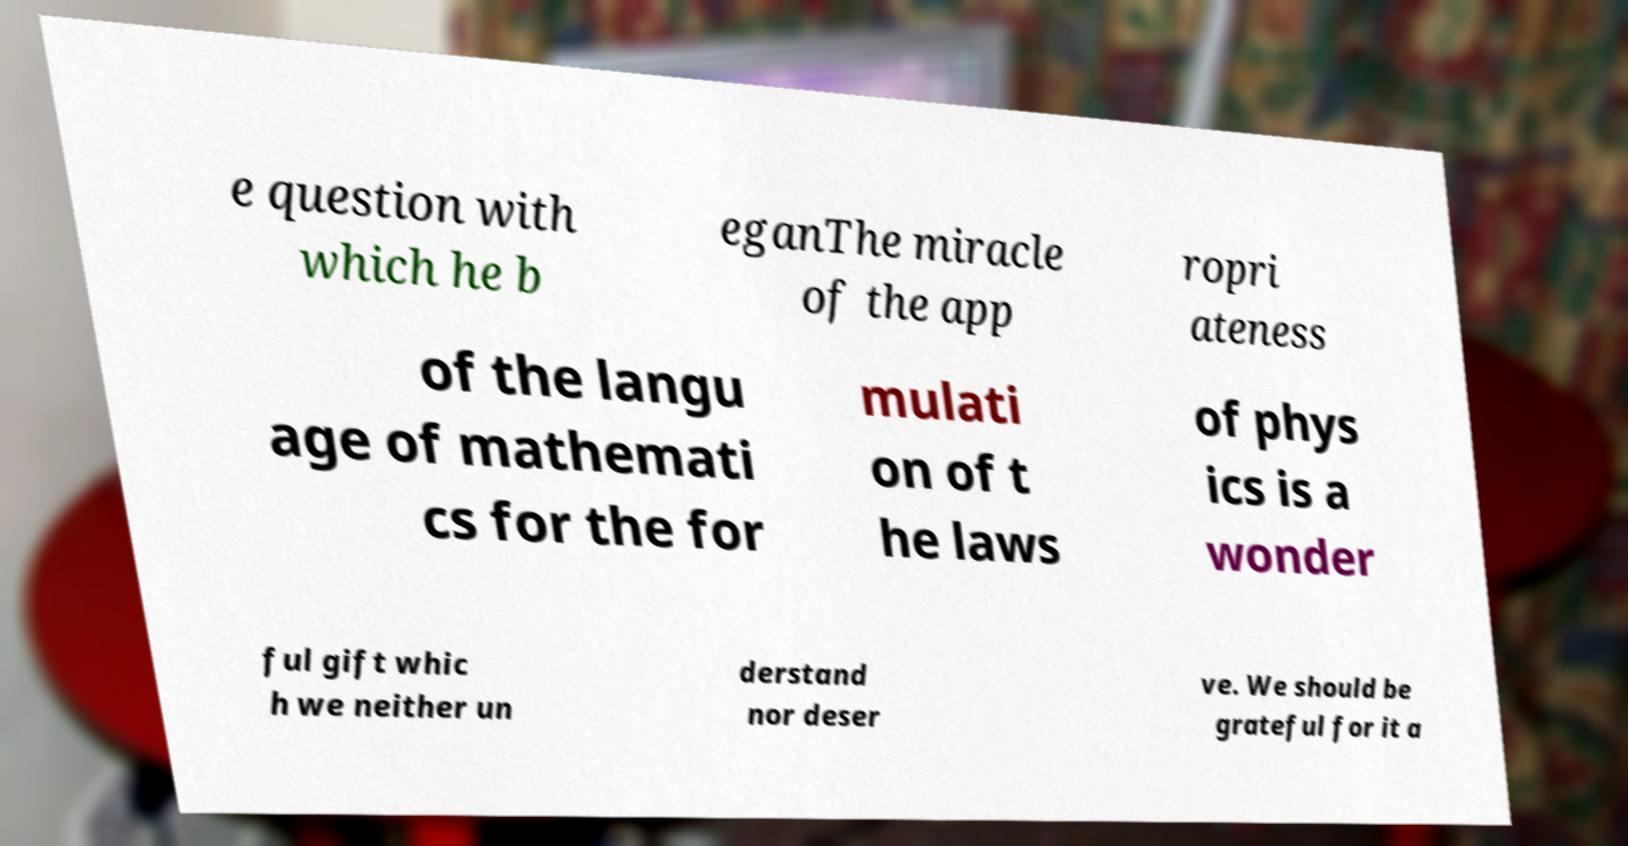Please read and relay the text visible in this image. What does it say? e question with which he b eganThe miracle of the app ropri ateness of the langu age of mathemati cs for the for mulati on of t he laws of phys ics is a wonder ful gift whic h we neither un derstand nor deser ve. We should be grateful for it a 